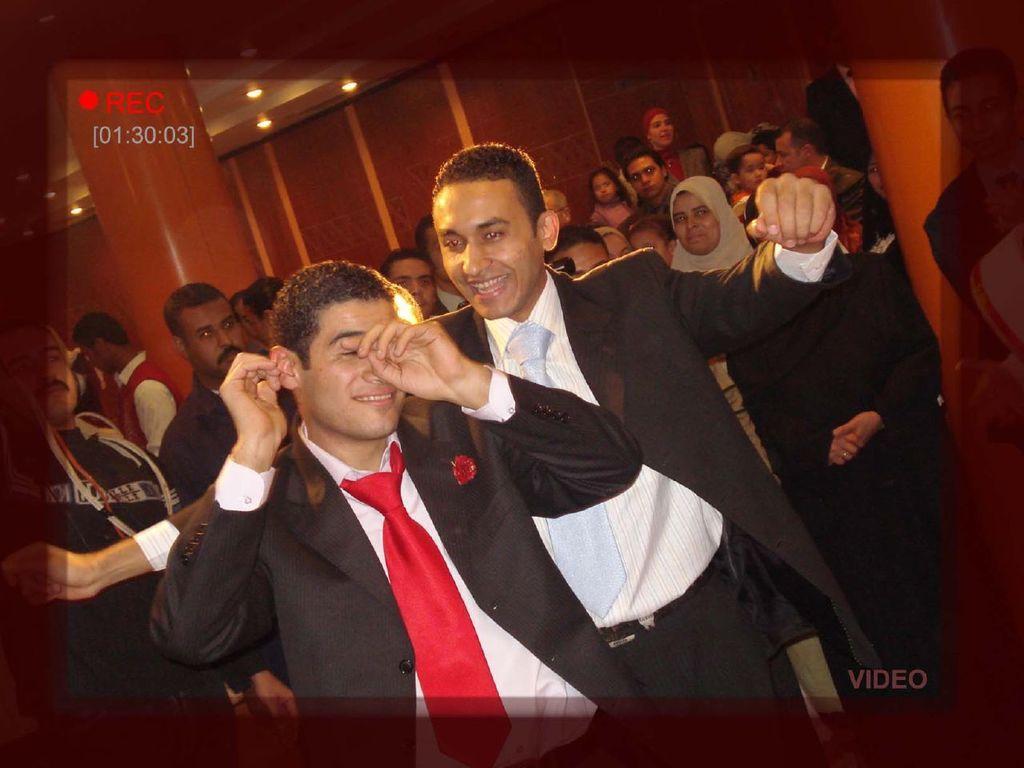How would you summarize this image in a sentence or two? In this image we can see people. In the background there are pillars and we can see a wall. At the top there are lights. 